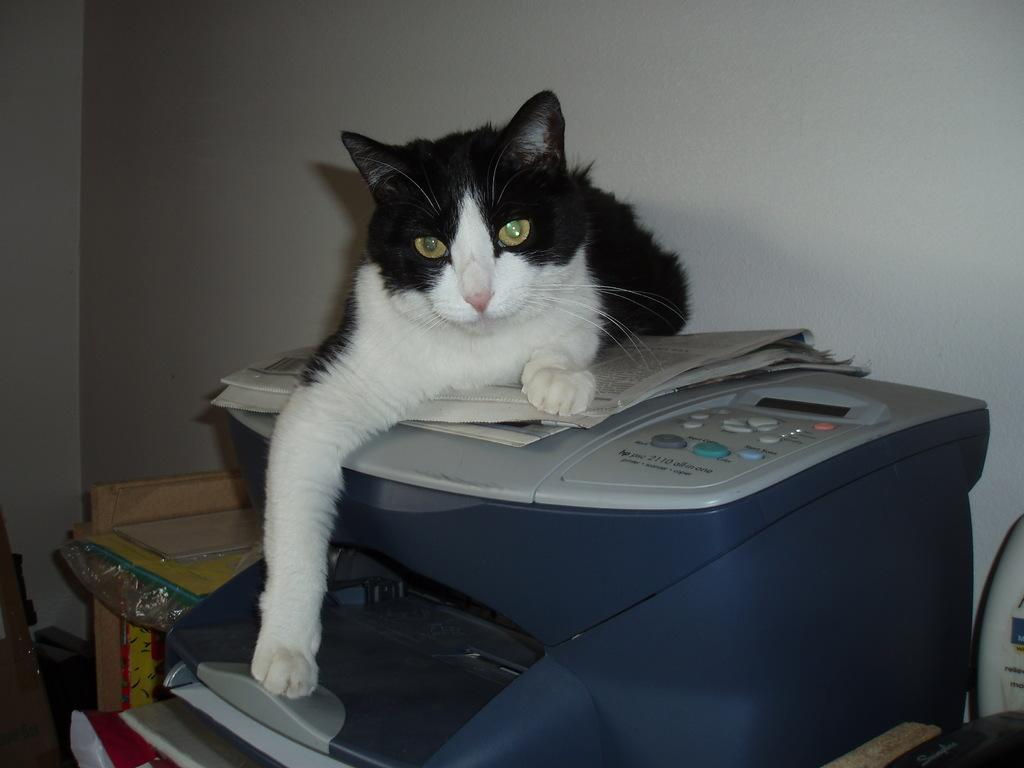What type of animal is in the image? There is a black and white cat in the image. What is the cat sitting on? The cat is sitting on a printer. What is the cat doing in the image? The cat is looking at the camera. What can be seen in the background of the image? There is a white wall in the background of the image. How many mittens are hanging on the wall in the image? There are no mittens present in the image. What type of metal is visible in the image? There is no metal, specifically zinc, visible in the image. 